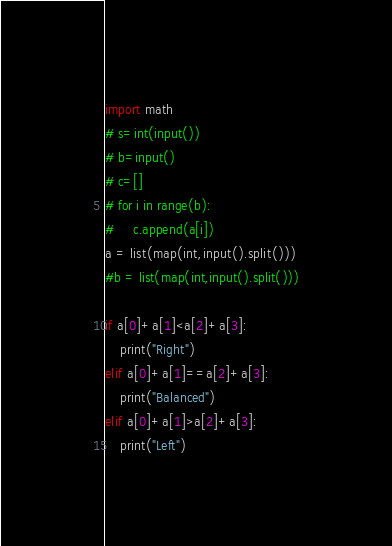<code> <loc_0><loc_0><loc_500><loc_500><_Python_>import math
# s=int(input())
# b=input()
# c=[]
# for i in range(b):
#     c.append(a[i])
a = list(map(int,input().split()))
#b = list(map(int,input().split()))

if a[0]+a[1]<a[2]+a[3]:
    print("Right")
elif a[0]+a[1]==a[2]+a[3]:
    print("Balanced")
elif a[0]+a[1]>a[2]+a[3]:
    print("Left")</code> 